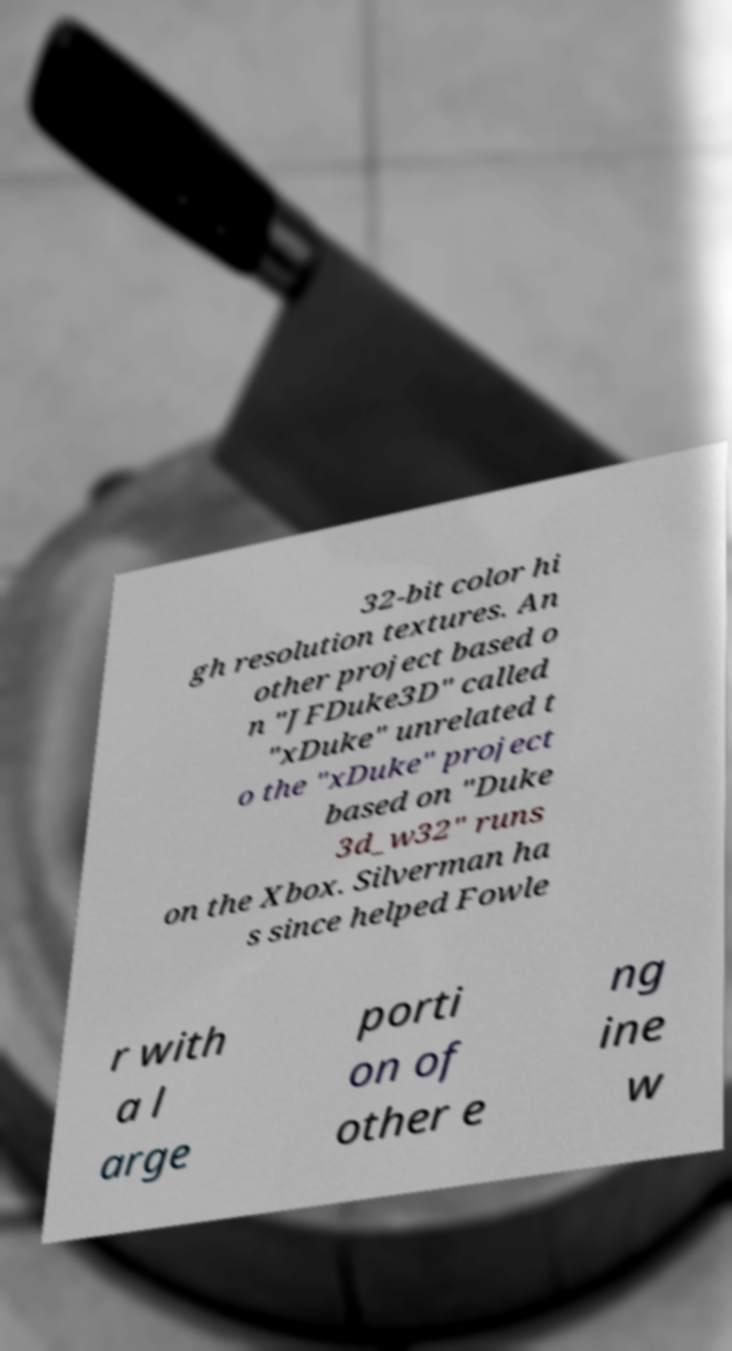There's text embedded in this image that I need extracted. Can you transcribe it verbatim? 32-bit color hi gh resolution textures. An other project based o n "JFDuke3D" called "xDuke" unrelated t o the "xDuke" project based on "Duke 3d_w32" runs on the Xbox. Silverman ha s since helped Fowle r with a l arge porti on of other e ng ine w 